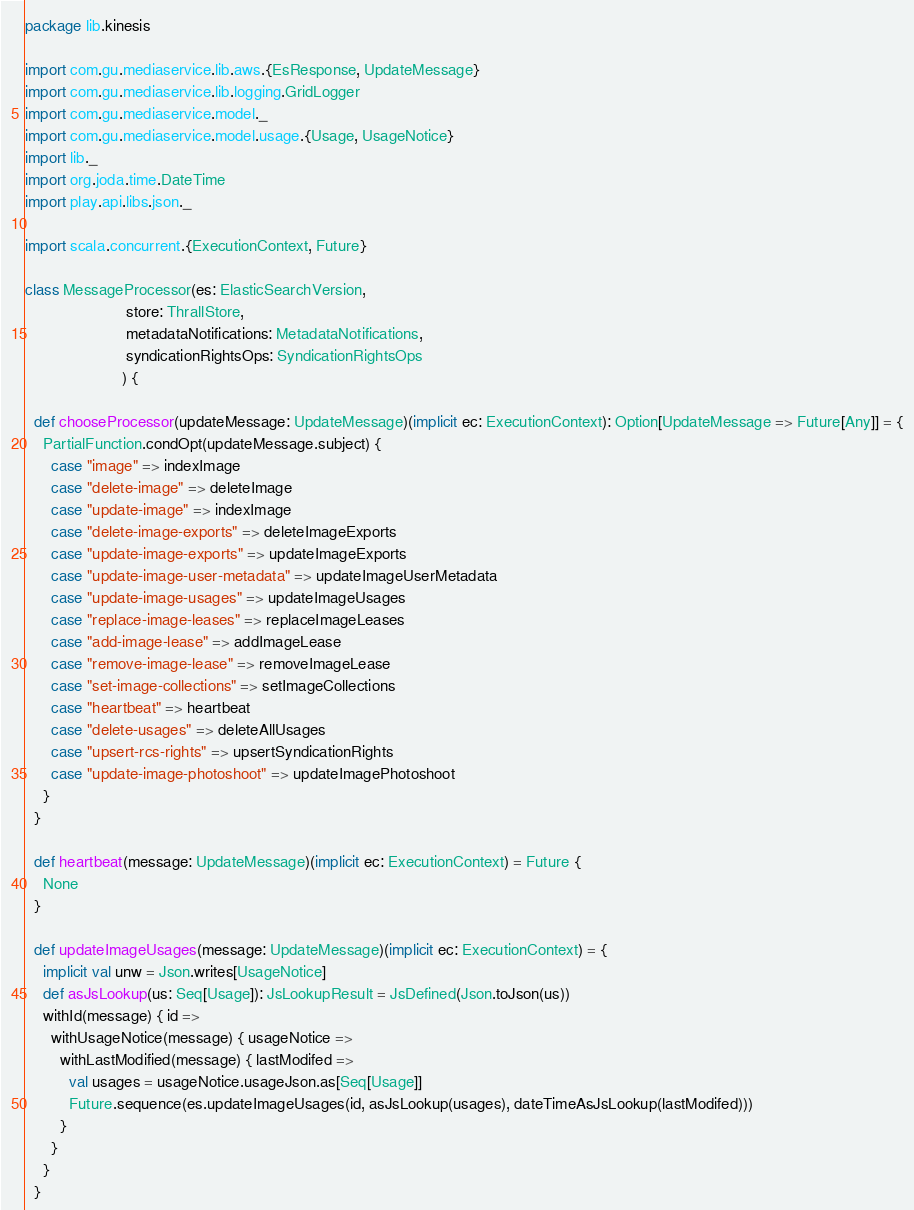<code> <loc_0><loc_0><loc_500><loc_500><_Scala_>package lib.kinesis

import com.gu.mediaservice.lib.aws.{EsResponse, UpdateMessage}
import com.gu.mediaservice.lib.logging.GridLogger
import com.gu.mediaservice.model._
import com.gu.mediaservice.model.usage.{Usage, UsageNotice}
import lib._
import org.joda.time.DateTime
import play.api.libs.json._

import scala.concurrent.{ExecutionContext, Future}

class MessageProcessor(es: ElasticSearchVersion,
                       store: ThrallStore,
                       metadataNotifications: MetadataNotifications,
                       syndicationRightsOps: SyndicationRightsOps
                      ) {

  def chooseProcessor(updateMessage: UpdateMessage)(implicit ec: ExecutionContext): Option[UpdateMessage => Future[Any]] = {
    PartialFunction.condOpt(updateMessage.subject) {
      case "image" => indexImage
      case "delete-image" => deleteImage
      case "update-image" => indexImage
      case "delete-image-exports" => deleteImageExports
      case "update-image-exports" => updateImageExports
      case "update-image-user-metadata" => updateImageUserMetadata
      case "update-image-usages" => updateImageUsages
      case "replace-image-leases" => replaceImageLeases
      case "add-image-lease" => addImageLease
      case "remove-image-lease" => removeImageLease
      case "set-image-collections" => setImageCollections
      case "heartbeat" => heartbeat
      case "delete-usages" => deleteAllUsages
      case "upsert-rcs-rights" => upsertSyndicationRights
      case "update-image-photoshoot" => updateImagePhotoshoot
    }
  }

  def heartbeat(message: UpdateMessage)(implicit ec: ExecutionContext) = Future {
    None
  }

  def updateImageUsages(message: UpdateMessage)(implicit ec: ExecutionContext) = {
    implicit val unw = Json.writes[UsageNotice]
    def asJsLookup(us: Seq[Usage]): JsLookupResult = JsDefined(Json.toJson(us))
    withId(message) { id =>
      withUsageNotice(message) { usageNotice =>
        withLastModified(message) { lastModifed =>
          val usages = usageNotice.usageJson.as[Seq[Usage]]
          Future.sequence(es.updateImageUsages(id, asJsLookup(usages), dateTimeAsJsLookup(lastModifed)))
        }
      }
    }
  }
</code> 